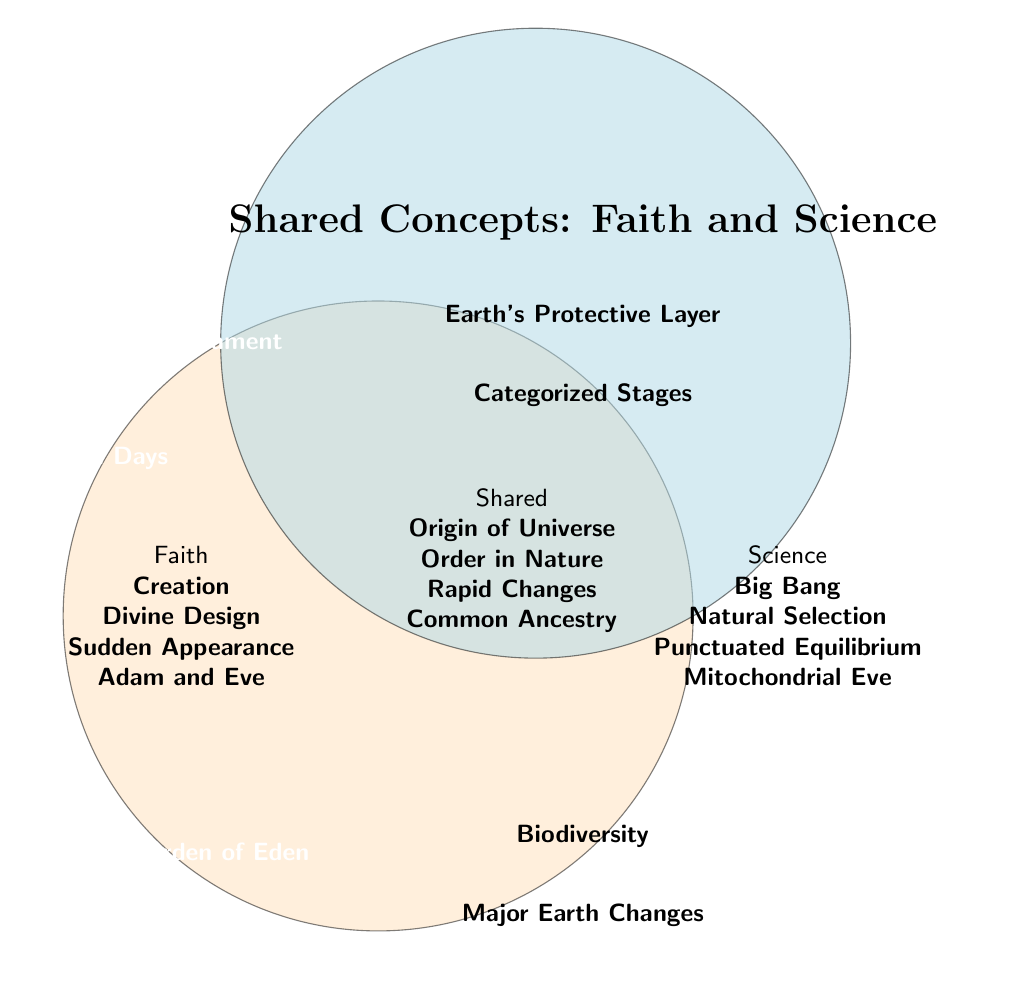What's the title of the figure? The title of the figure is located at the top and is the largest text, indicating the main topic of the diagram.
Answer: Shared Concepts: Faith and Science How many categories are listed under "Shared"? The categories are listed in the intersection section labeled "Shared." Count them to find the total.
Answer: Four What concept is shared between "Noah's Flood" and "Geological Catastrophes"? Both "Noah's Flood" and "Geological Catastrophes" are connected by a shared concept, which is "Major Earth Changes."
Answer: Major Earth Changes Is "Biodiversity" a shared concept? "Biodiversity" is located in the intersection section, meaning it is a part of the "Shared" concepts.
Answer: Yes Which theological concept is paired with "Natural Selection" in the shared category? "Divine Design" from the Faith section is connected to "Natural Selection" in the Science section, and both share the concept of "Order in Nature."
Answer: Order in Nature What connects "Adam and Eve" to scientific theory involving genetics? "Adam and Eve" from Faith is connected to "Mitochondrial Eve" in Science through the shared category "Common Ancestry."
Answer: Common Ancestry How is the concept of "Seven Days" from faith compared with a scientific view in the shared category? "Seven Days" in the Faith section is compared to "Time Periods" in the Science section, sharing the concept of "Categorized Stages."
Answer: Categorized Stages What shared concept is illustrated by "Firmament" and "Atmosphere"? "Firmament" from Faith and "Atmosphere" from Science both relate to the shared concept "Earth's Protective Layer."
Answer: Earth's Protective Layer Which shared concept points to a naturally explained and theologically significant origin of the universe? "Creation" in Faith and "Big Bang" in Science converge on the shared concept of "Origin of Universe" in the diagram.
Answer: Origin of Universe 